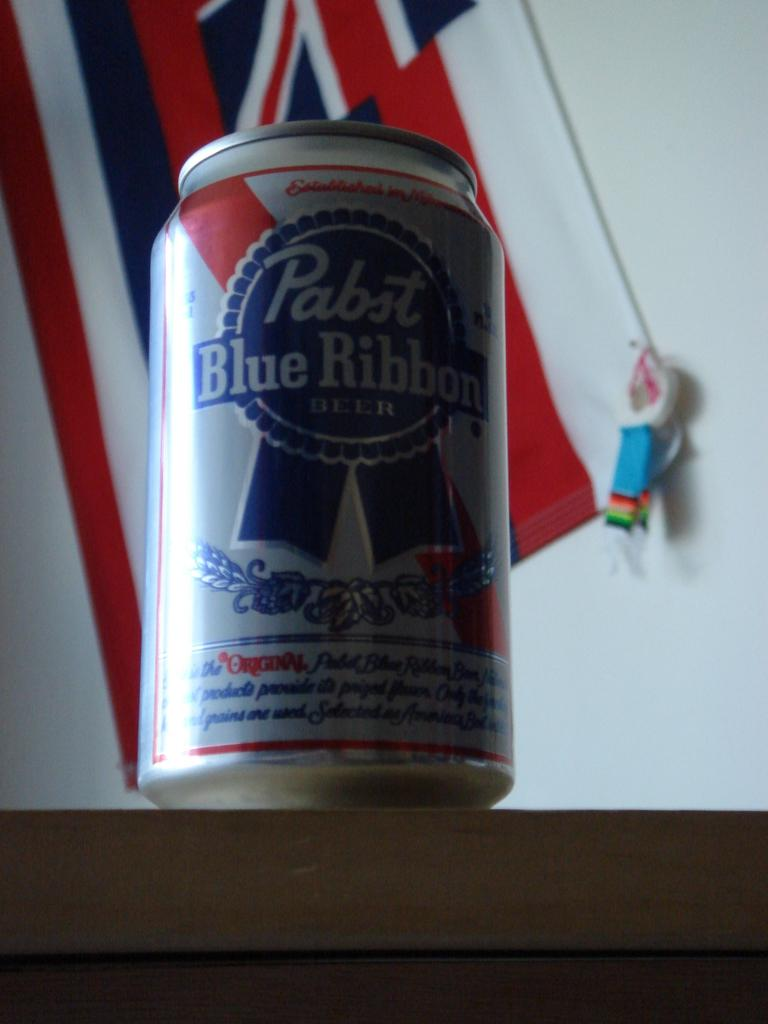<image>
Present a compact description of the photo's key features. a blue ribbon beer can that is on a table 